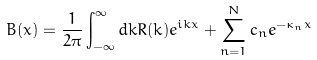<formula> <loc_0><loc_0><loc_500><loc_500>B ( x ) = \frac { 1 } { 2 \pi } \int _ { - \infty } ^ { \infty } d k R ( k ) e ^ { i k x } + \sum _ { n = 1 } ^ { N } c _ { n } e ^ { - \kappa _ { n } x }</formula> 